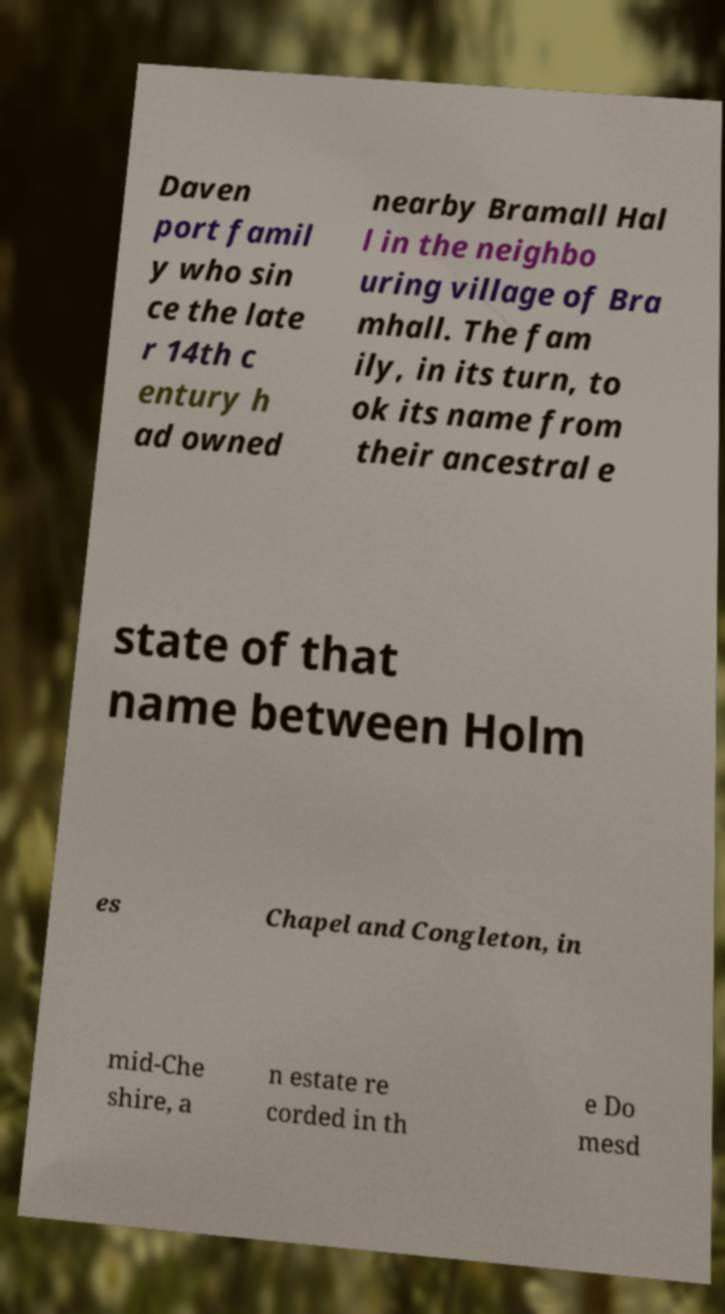Could you extract and type out the text from this image? Daven port famil y who sin ce the late r 14th c entury h ad owned nearby Bramall Hal l in the neighbo uring village of Bra mhall. The fam ily, in its turn, to ok its name from their ancestral e state of that name between Holm es Chapel and Congleton, in mid-Che shire, a n estate re corded in th e Do mesd 